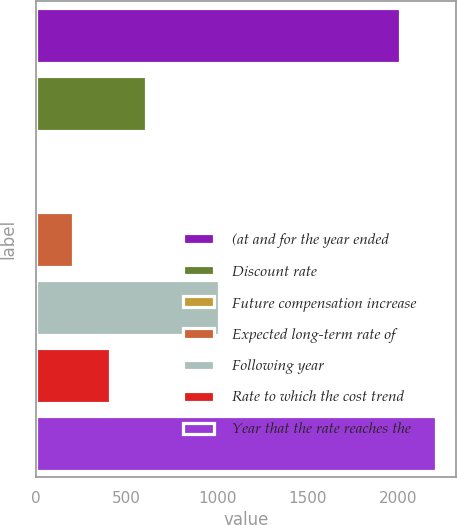Convert chart. <chart><loc_0><loc_0><loc_500><loc_500><bar_chart><fcel>(at and for the year ended<fcel>Discount rate<fcel>Future compensation increase<fcel>Expected long-term rate of<fcel>Following year<fcel>Rate to which the cost trend<fcel>Year that the rate reaches the<nl><fcel>2010<fcel>608.2<fcel>4<fcel>205.4<fcel>1011<fcel>406.8<fcel>2211.4<nl></chart> 